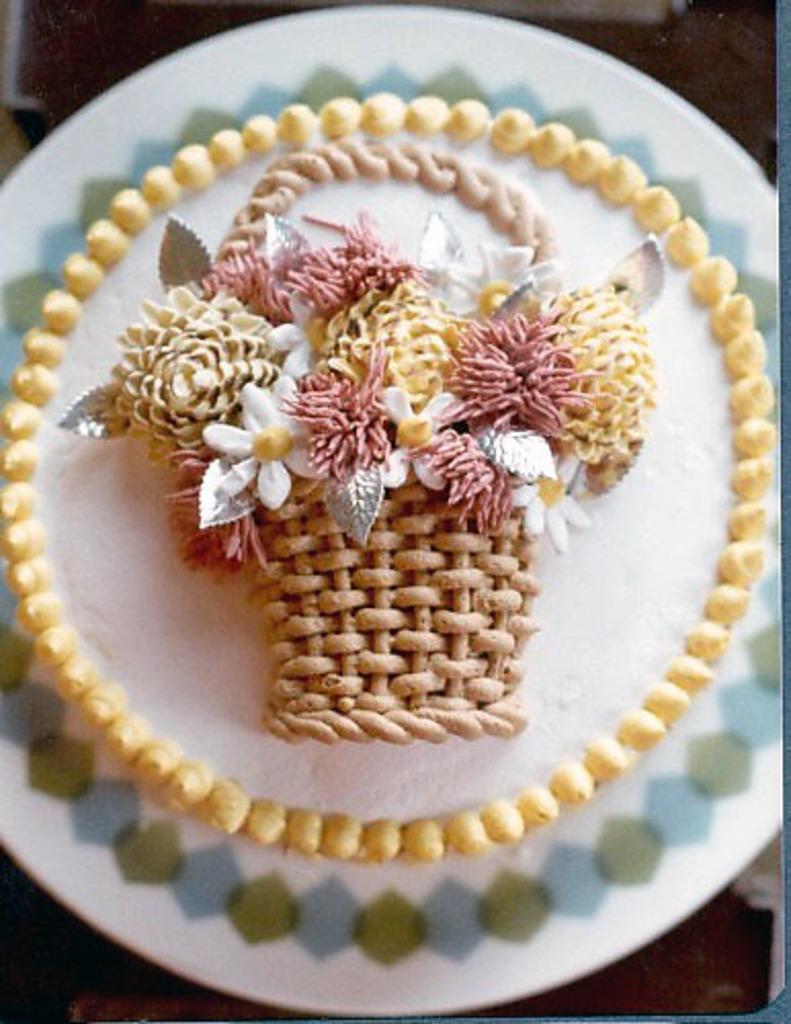Could you give a brief overview of what you see in this image? In the center of the image we can see a plate. In the plate, we can see a cake. In the background, we can see it is blurred. 